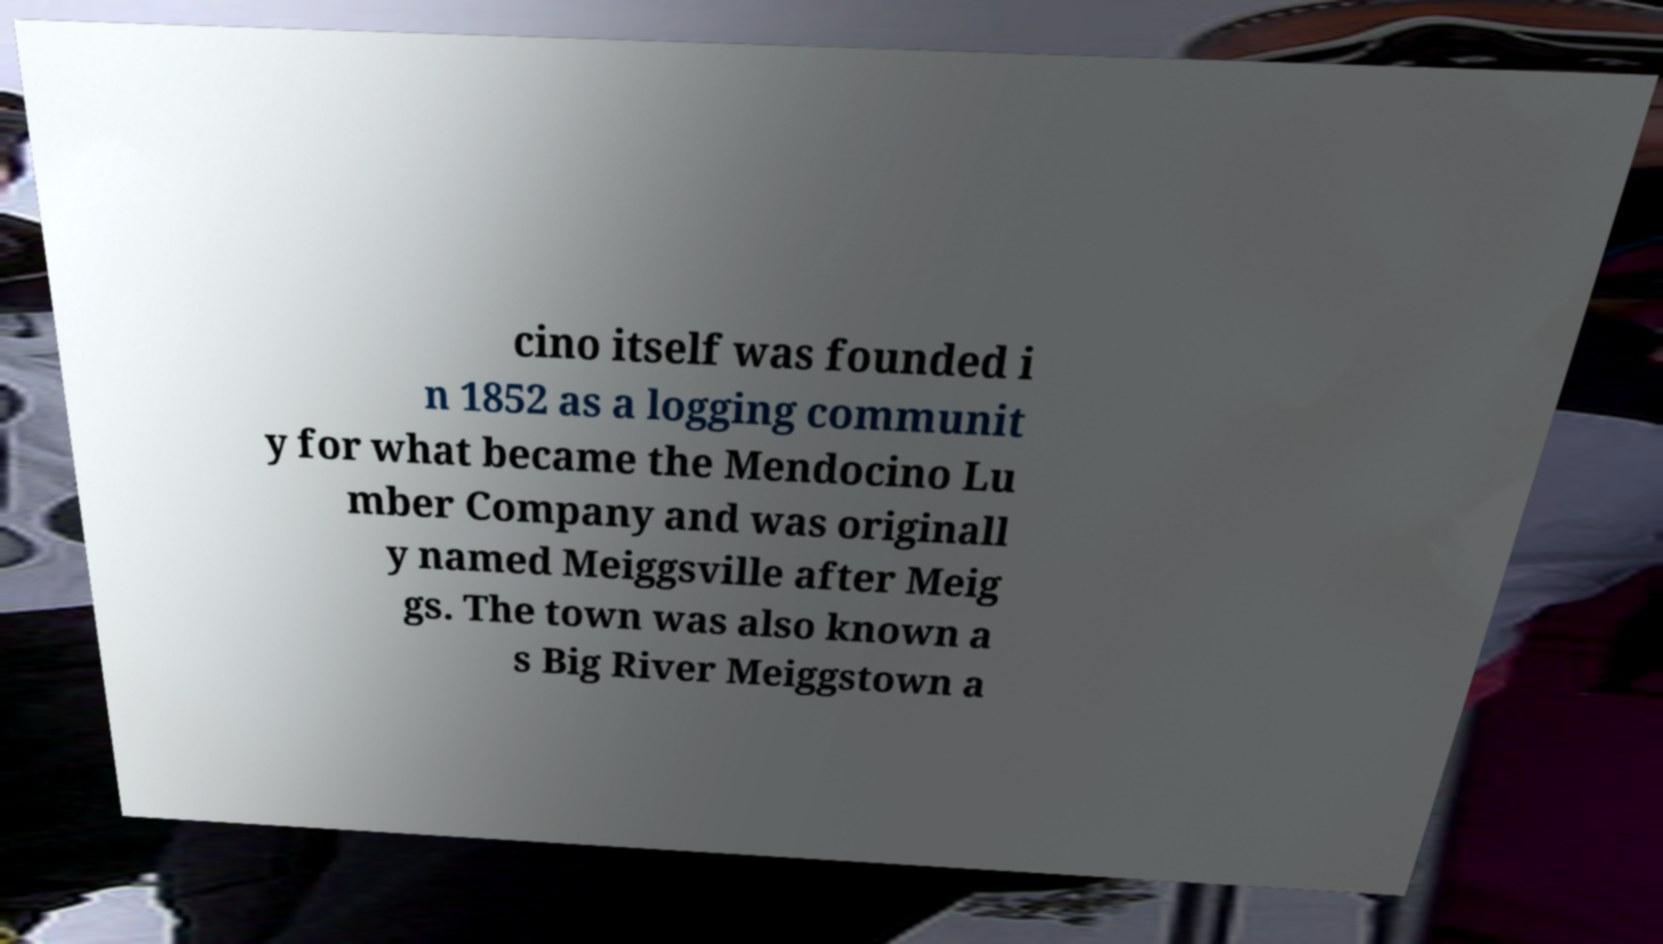What messages or text are displayed in this image? I need them in a readable, typed format. cino itself was founded i n 1852 as a logging communit y for what became the Mendocino Lu mber Company and was originall y named Meiggsville after Meig gs. The town was also known a s Big River Meiggstown a 